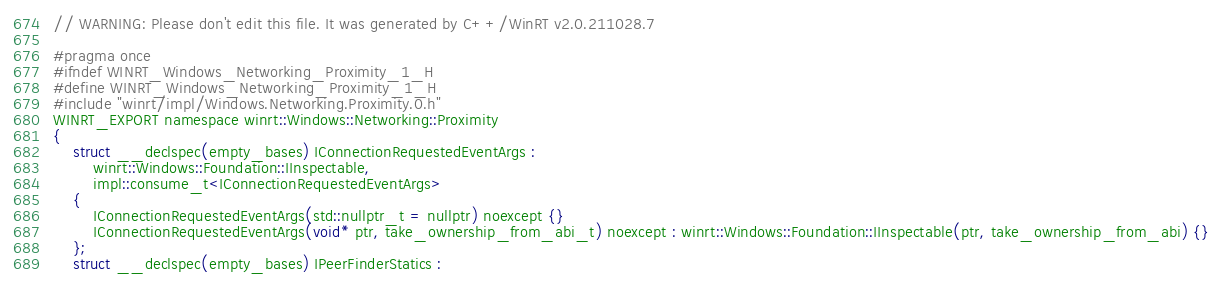<code> <loc_0><loc_0><loc_500><loc_500><_C_>// WARNING: Please don't edit this file. It was generated by C++/WinRT v2.0.211028.7

#pragma once
#ifndef WINRT_Windows_Networking_Proximity_1_H
#define WINRT_Windows_Networking_Proximity_1_H
#include "winrt/impl/Windows.Networking.Proximity.0.h"
WINRT_EXPORT namespace winrt::Windows::Networking::Proximity
{
    struct __declspec(empty_bases) IConnectionRequestedEventArgs :
        winrt::Windows::Foundation::IInspectable,
        impl::consume_t<IConnectionRequestedEventArgs>
    {
        IConnectionRequestedEventArgs(std::nullptr_t = nullptr) noexcept {}
        IConnectionRequestedEventArgs(void* ptr, take_ownership_from_abi_t) noexcept : winrt::Windows::Foundation::IInspectable(ptr, take_ownership_from_abi) {}
    };
    struct __declspec(empty_bases) IPeerFinderStatics :</code> 